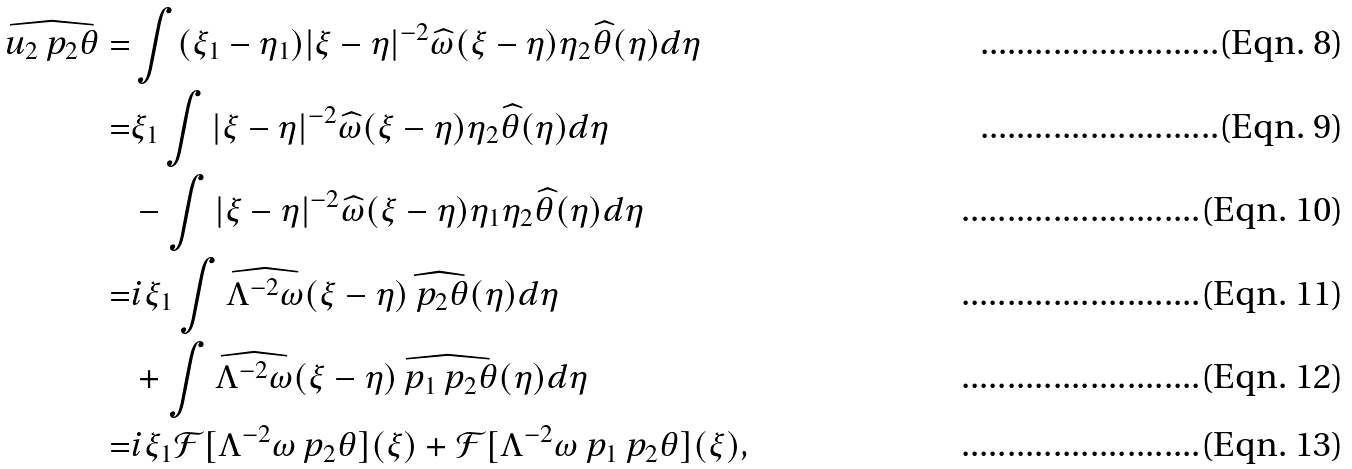Convert formula to latex. <formula><loc_0><loc_0><loc_500><loc_500>\widehat { u _ { 2 } \ p _ { 2 } \theta } = & \int ( \xi _ { 1 } - \eta _ { 1 } ) | \xi - \eta | ^ { - 2 } \widehat { \omega } ( \xi - \eta ) \eta _ { 2 } \widehat { \theta } ( \eta ) d \eta \\ = & \xi _ { 1 } \int | \xi - \eta | ^ { - 2 } \widehat { \omega } ( \xi - \eta ) \eta _ { 2 } \widehat { \theta } ( \eta ) d \eta \\ & - \int | \xi - \eta | ^ { - 2 } \widehat { \omega } ( \xi - \eta ) \eta _ { 1 } \eta _ { 2 } \widehat { \theta } ( \eta ) d \eta \\ = & i \xi _ { 1 } \int \widehat { \Lambda ^ { - 2 } \omega } ( \xi - \eta ) \widehat { \ p _ { 2 } \theta } ( \eta ) d \eta \\ & + \int \widehat { \Lambda ^ { - 2 } \omega } ( \xi - \eta ) \widehat { \ p _ { 1 } \ p _ { 2 } \theta } ( \eta ) d \eta \\ = & i \xi _ { 1 } \mathcal { F } [ \Lambda ^ { - 2 } \omega \ p _ { 2 } \theta ] ( \xi ) + \mathcal { F } [ \Lambda ^ { - 2 } \omega \ p _ { 1 } \ p _ { 2 } \theta ] ( \xi ) ,</formula> 